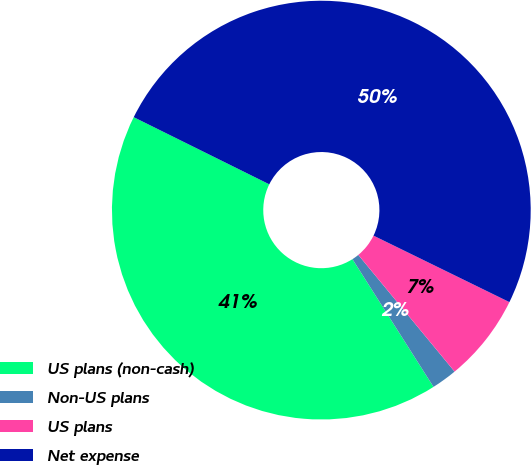Convert chart. <chart><loc_0><loc_0><loc_500><loc_500><pie_chart><fcel>US plans (non-cash)<fcel>Non-US plans<fcel>US plans<fcel>Net expense<nl><fcel>41.32%<fcel>1.98%<fcel>6.78%<fcel>49.92%<nl></chart> 